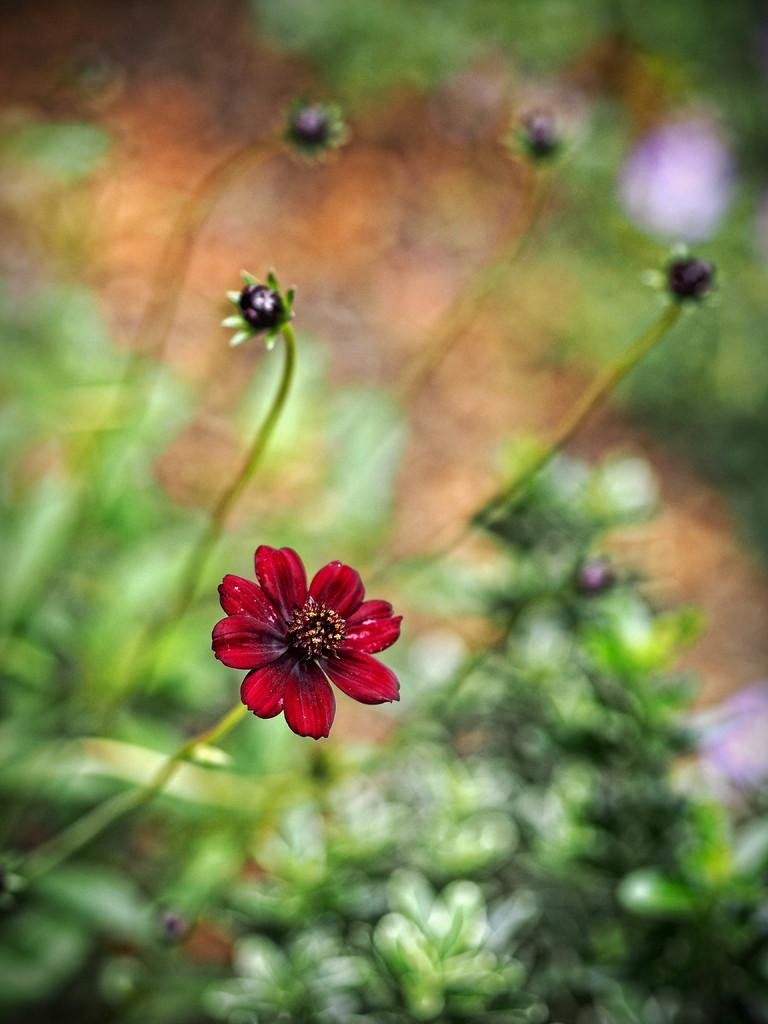What type of flower is in the image? There is a red color flower in the image. Can you describe the background of the image? The background of the image is blurred. How many toes can be seen on the mountain in the image? There is no mountain or toes present in the image; it features a red color flower with a blurred background. 